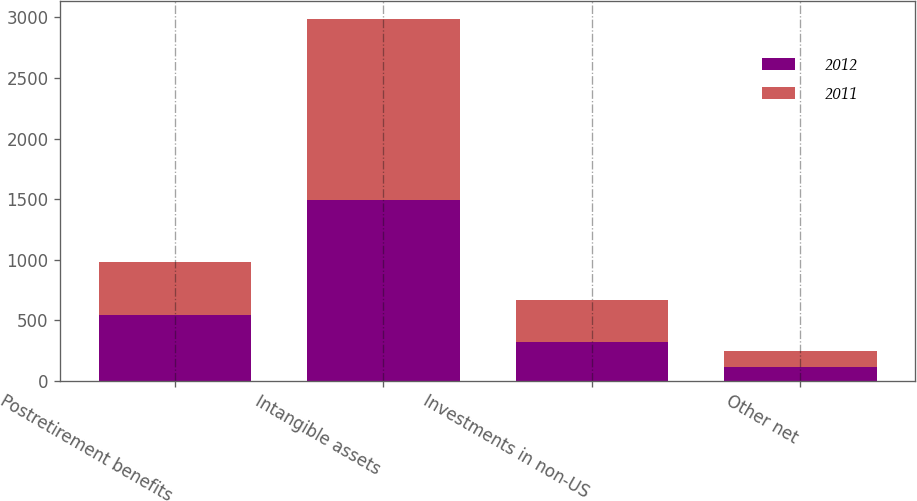<chart> <loc_0><loc_0><loc_500><loc_500><stacked_bar_chart><ecel><fcel>Postretirement benefits<fcel>Intangible assets<fcel>Investments in non-US<fcel>Other net<nl><fcel>2012<fcel>543<fcel>1490<fcel>317<fcel>114<nl><fcel>2011<fcel>440<fcel>1498<fcel>349<fcel>132<nl></chart> 